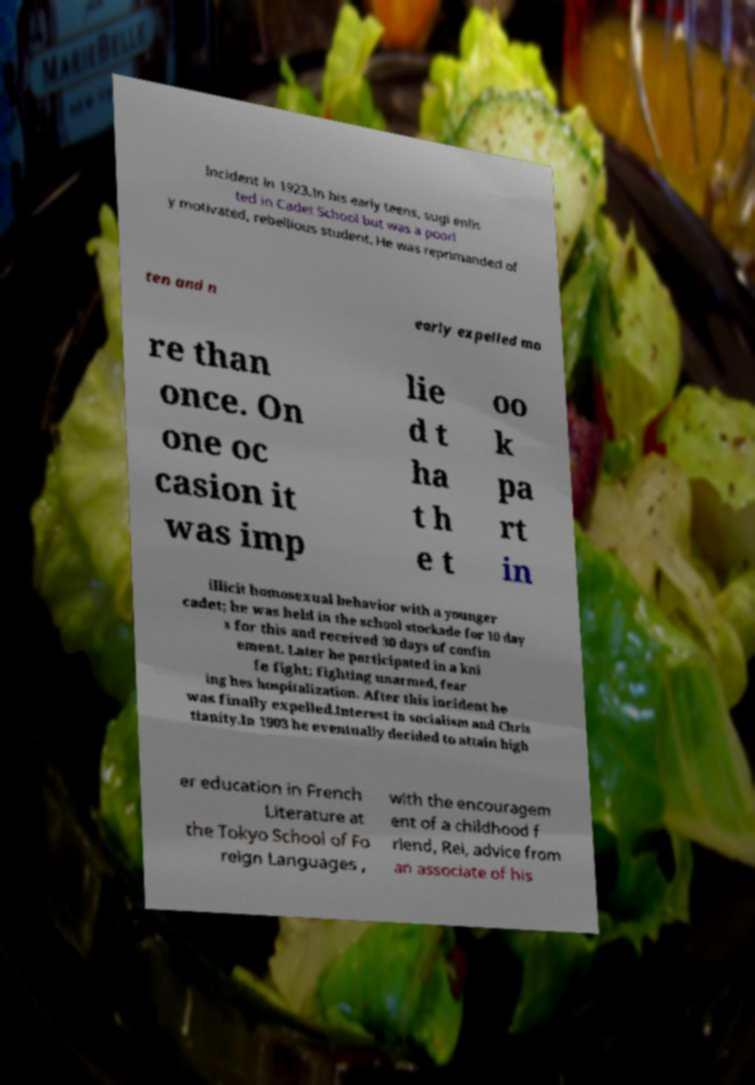What messages or text are displayed in this image? I need them in a readable, typed format. Incident in 1923.In his early teens, sugi enlis ted in Cadet School but was a poorl y motivated, rebellious student. He was reprimanded of ten and n early expelled mo re than once. On one oc casion it was imp lie d t ha t h e t oo k pa rt in illicit homosexual behavior with a younger cadet; he was held in the school stockade for 10 day s for this and received 30 days of confin ement. Later he participated in a kni fe fight; fighting unarmed, fear ing hes hospitalization. After this incident he was finally expelled.Interest in socialism and Chris tianity.In 1903 he eventually decided to attain high er education in French Literature at the Tokyo School of Fo reign Languages , with the encouragem ent of a childhood f riend, Rei, advice from an associate of his 